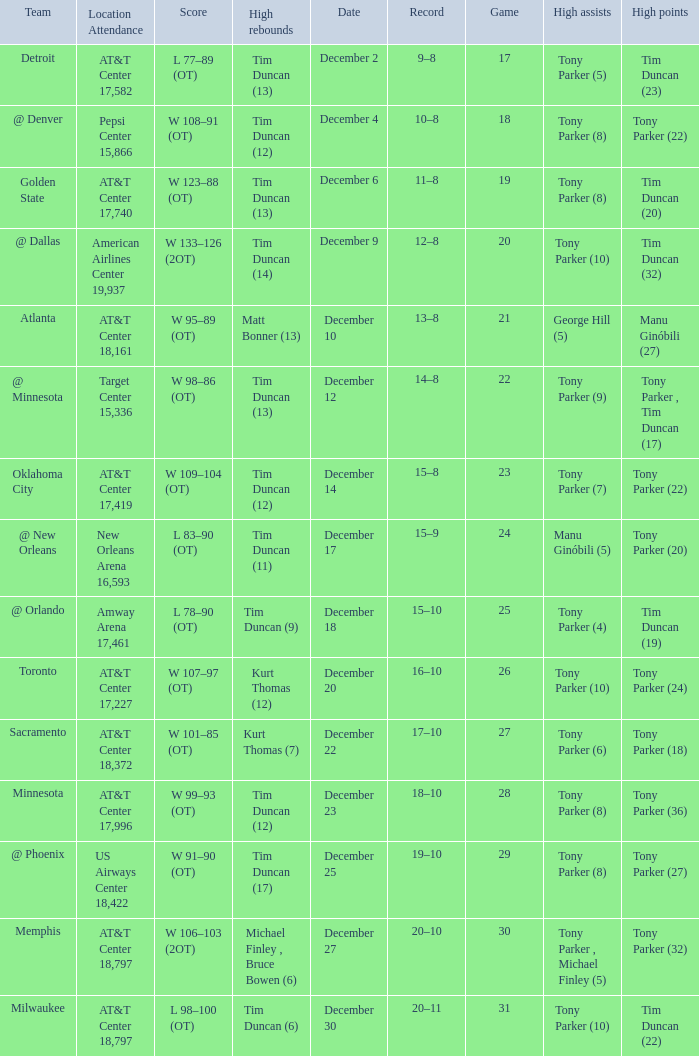What team has tony parker (10) as the high assists, kurt thomas (12) as the high rebounds? Toronto. 